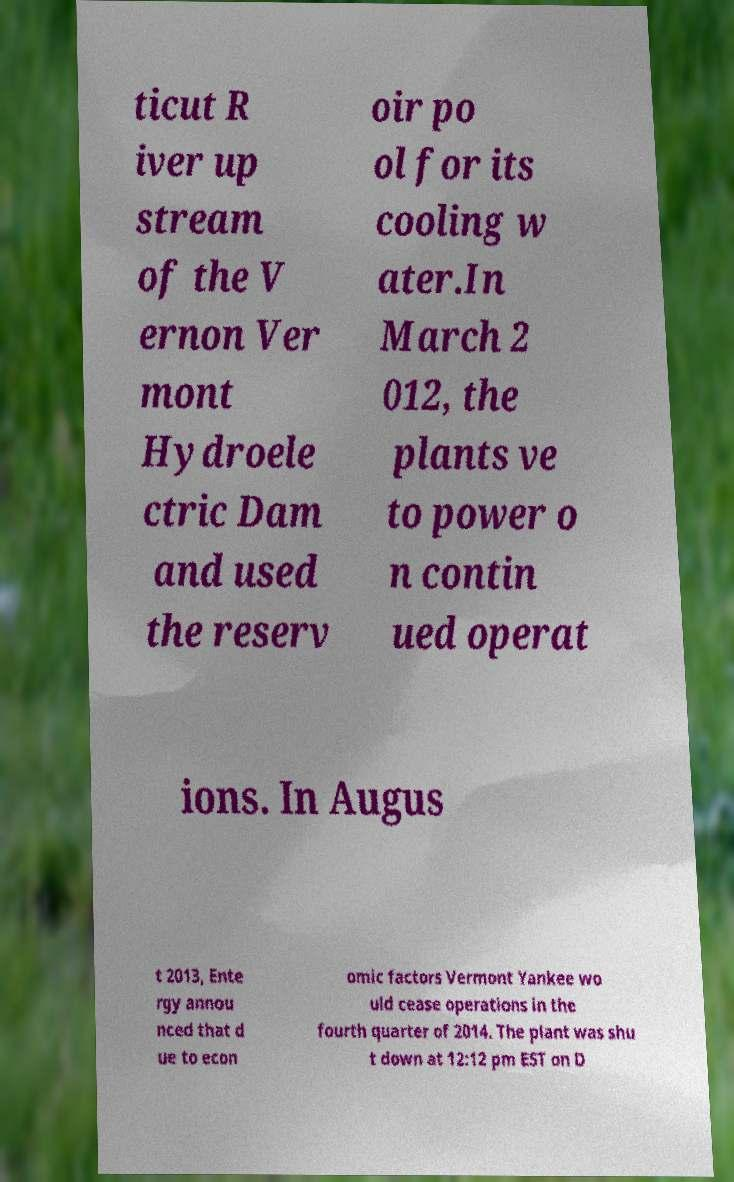For documentation purposes, I need the text within this image transcribed. Could you provide that? ticut R iver up stream of the V ernon Ver mont Hydroele ctric Dam and used the reserv oir po ol for its cooling w ater.In March 2 012, the plants ve to power o n contin ued operat ions. In Augus t 2013, Ente rgy annou nced that d ue to econ omic factors Vermont Yankee wo uld cease operations in the fourth quarter of 2014. The plant was shu t down at 12:12 pm EST on D 